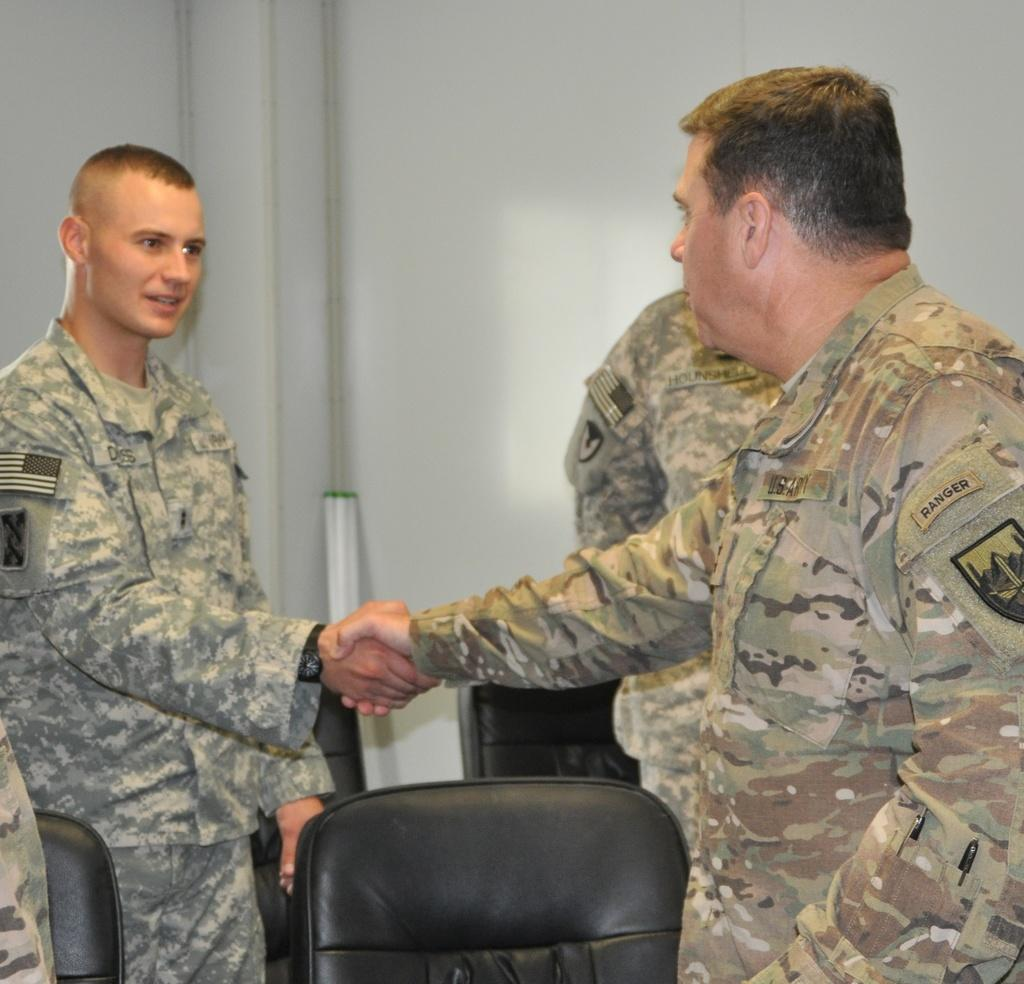How many people are in the image? There are two men in the image. What are the men wearing? Both men are wearing uniforms. What are the men doing in the image? The men are shaking hands. What type of furniture is visible in the image? There are black color chairs in the image. What type of paint is being used by the men in the image? There is no paint or painting activity depicted in the image. What flag is being raised by the men in the image? There is no flag or flag-raising activity depicted in the image. 